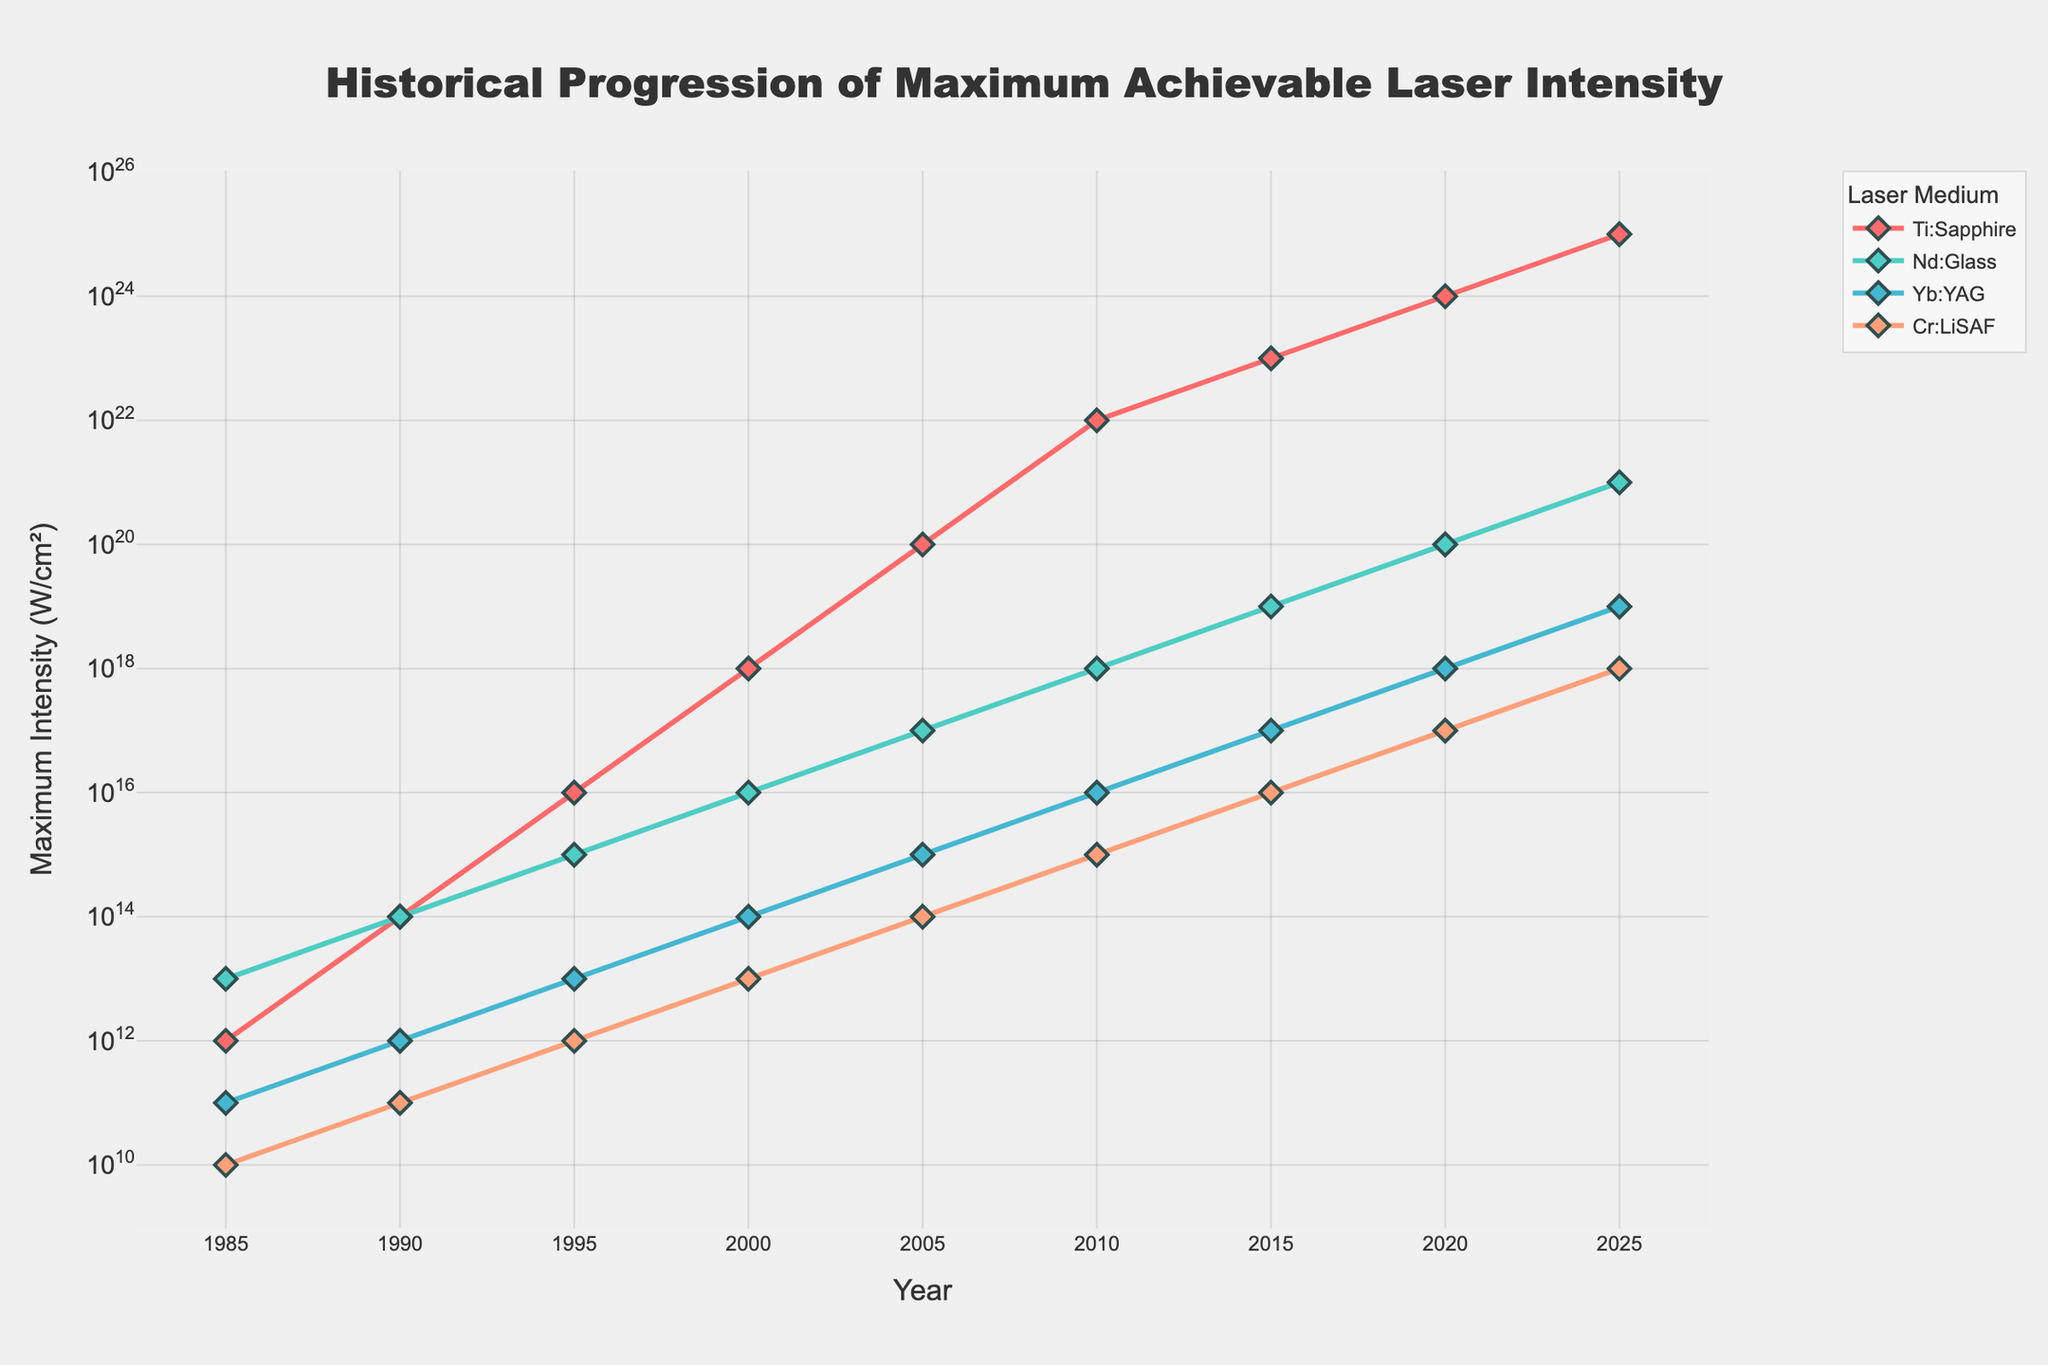What was the maximum intensity achieved by the Ti:Sapphire laser medium in 2010? The data plot shows the maximum intensities achieved by different laser media over the years. For Ti:Sapphire in 2010, the y-value corresponding to the year 2010 is 10^22 W/cm².
Answer: 10^22 W/cm² Which laser medium had the greatest increase in maximum intensity between 1995 and 2000? By comparing the y-values for 1995 and 2000, we compute the increase for each laser medium. Ti:Sapphire: 10^18 - 10^16 = 10^18; Nd:Glass: 10^16 - 10^15 = 9×10^15; Yb:YAG: 10^14 - 10^13 = 9×10^13; Cr:LiSAF: 10^13 - 10^12 = 9×10^12. Ti:Sapphire had the greatest increase.
Answer: Ti:Sapphire Which laser medium had the lowest maximum intensity in 1985 and what was the value? By looking at the plot for the year 1985, we identify the lowest intensity value. Cr:LiSAF has the lowest maximum intensity of 10^10 W/cm².
Answer: Cr:LiSAF, 10^10 W/cm² In which year did Nd:Glass laser medium overtake Yb:YAG in maximum intensity? To determine this, we compare the progression of Nd:Glass and Yb:YAG intensities. Nd:Glass overtakes Yb:YAG between 1985 and 1990.
Answer: 1985 to 1990 What is the difference in maximum intensity between Ti:Sapphire and Cr:LiSAF in 2020? We find the intensities for Ti:Sapphire (10^24 W/cm²) and Cr:LiSAF (10^17 W/cm²) in 2020 and compute the difference. 10^24 - 10^17 = 9.99×10^23 W/cm².
Answer: 9.99×10^23 W/cm² What trend do you observe in the progression of maximum intensity for Yb:YAG from 1985 to 2025? Observing the plot, Yb:YAG shows a steady exponential increase in maximum intensity over the years, starting from 10^11 W/cm² in 1985 to 10^19 W/cm² in 2025.
Answer: Steady exponential increase Among the laser media, which has the most consistent growth in maximum intensity over the years? By examining the slope consistency on the plot, we notice Yb:YAG has a steadily increasing trend without abrupt jumps compared to others.
Answer: Yb:YAG When did Ti:Sapphire first reach an intensity of 10^20 W/cm²? From the plot, Ti:Sapphire hits 10^20 W/cm² between 2005 and 2010.
Answer: Between 2005 and 2010 